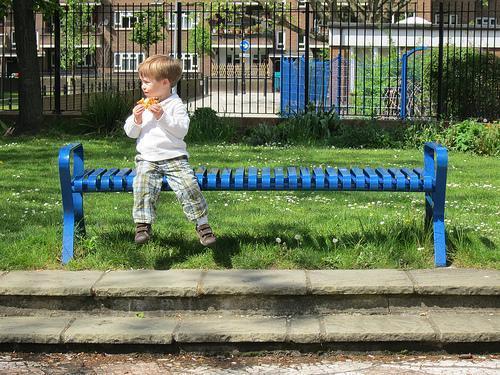How many boys are there?
Give a very brief answer. 1. How many muskrats are sitting on the bench?
Give a very brief answer. 0. 